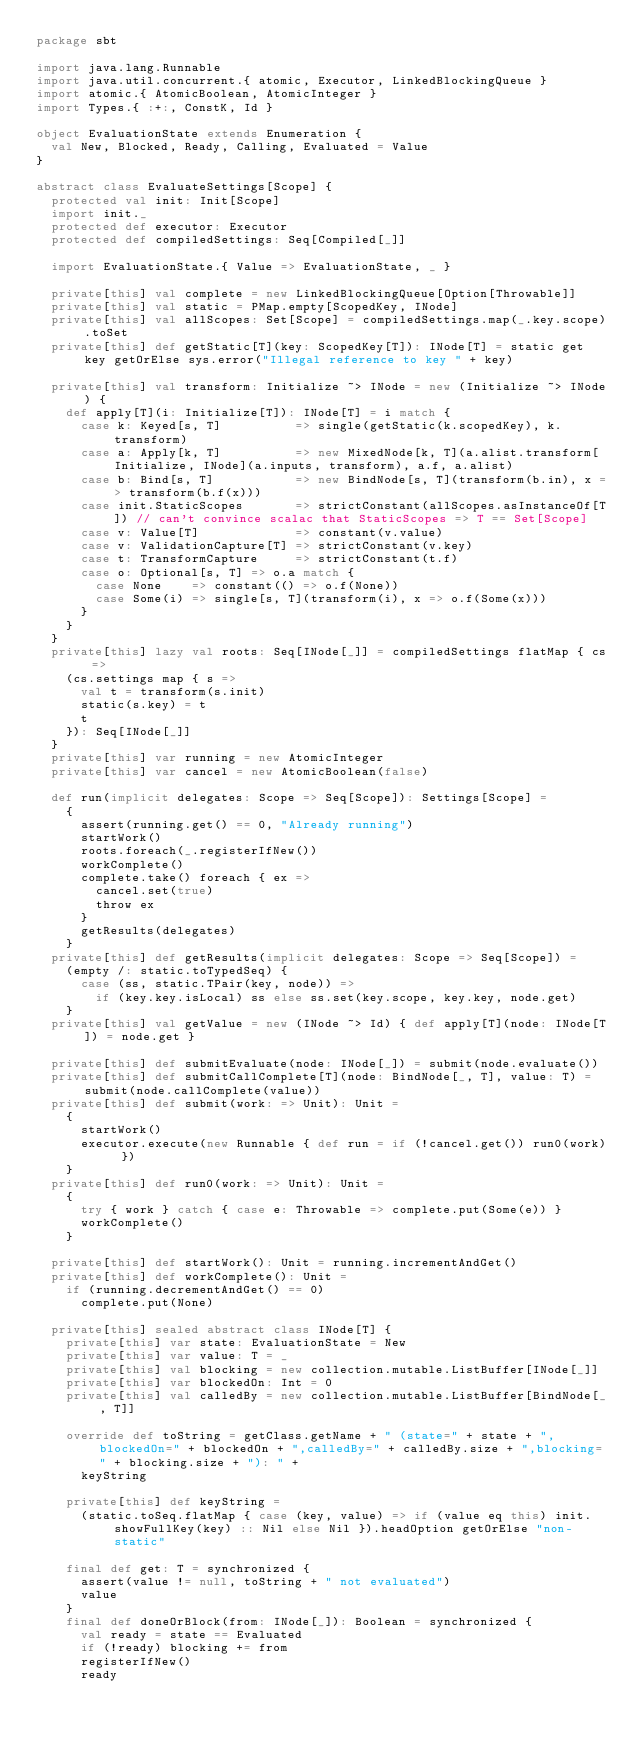<code> <loc_0><loc_0><loc_500><loc_500><_Scala_>package sbt

import java.lang.Runnable
import java.util.concurrent.{ atomic, Executor, LinkedBlockingQueue }
import atomic.{ AtomicBoolean, AtomicInteger }
import Types.{ :+:, ConstK, Id }

object EvaluationState extends Enumeration {
  val New, Blocked, Ready, Calling, Evaluated = Value
}

abstract class EvaluateSettings[Scope] {
  protected val init: Init[Scope]
  import init._
  protected def executor: Executor
  protected def compiledSettings: Seq[Compiled[_]]

  import EvaluationState.{ Value => EvaluationState, _ }

  private[this] val complete = new LinkedBlockingQueue[Option[Throwable]]
  private[this] val static = PMap.empty[ScopedKey, INode]
  private[this] val allScopes: Set[Scope] = compiledSettings.map(_.key.scope).toSet
  private[this] def getStatic[T](key: ScopedKey[T]): INode[T] = static get key getOrElse sys.error("Illegal reference to key " + key)

  private[this] val transform: Initialize ~> INode = new (Initialize ~> INode) {
    def apply[T](i: Initialize[T]): INode[T] = i match {
      case k: Keyed[s, T]          => single(getStatic(k.scopedKey), k.transform)
      case a: Apply[k, T]          => new MixedNode[k, T](a.alist.transform[Initialize, INode](a.inputs, transform), a.f, a.alist)
      case b: Bind[s, T]           => new BindNode[s, T](transform(b.in), x => transform(b.f(x)))
      case init.StaticScopes       => strictConstant(allScopes.asInstanceOf[T]) // can't convince scalac that StaticScopes => T == Set[Scope]
      case v: Value[T]             => constant(v.value)
      case v: ValidationCapture[T] => strictConstant(v.key)
      case t: TransformCapture     => strictConstant(t.f)
      case o: Optional[s, T] => o.a match {
        case None    => constant(() => o.f(None))
        case Some(i) => single[s, T](transform(i), x => o.f(Some(x)))
      }
    }
  }
  private[this] lazy val roots: Seq[INode[_]] = compiledSettings flatMap { cs =>
    (cs.settings map { s =>
      val t = transform(s.init)
      static(s.key) = t
      t
    }): Seq[INode[_]]
  }
  private[this] var running = new AtomicInteger
  private[this] var cancel = new AtomicBoolean(false)

  def run(implicit delegates: Scope => Seq[Scope]): Settings[Scope] =
    {
      assert(running.get() == 0, "Already running")
      startWork()
      roots.foreach(_.registerIfNew())
      workComplete()
      complete.take() foreach { ex =>
        cancel.set(true)
        throw ex
      }
      getResults(delegates)
    }
  private[this] def getResults(implicit delegates: Scope => Seq[Scope]) =
    (empty /: static.toTypedSeq) {
      case (ss, static.TPair(key, node)) =>
        if (key.key.isLocal) ss else ss.set(key.scope, key.key, node.get)
    }
  private[this] val getValue = new (INode ~> Id) { def apply[T](node: INode[T]) = node.get }

  private[this] def submitEvaluate(node: INode[_]) = submit(node.evaluate())
  private[this] def submitCallComplete[T](node: BindNode[_, T], value: T) = submit(node.callComplete(value))
  private[this] def submit(work: => Unit): Unit =
    {
      startWork()
      executor.execute(new Runnable { def run = if (!cancel.get()) run0(work) })
    }
  private[this] def run0(work: => Unit): Unit =
    {
      try { work } catch { case e: Throwable => complete.put(Some(e)) }
      workComplete()
    }

  private[this] def startWork(): Unit = running.incrementAndGet()
  private[this] def workComplete(): Unit =
    if (running.decrementAndGet() == 0)
      complete.put(None)

  private[this] sealed abstract class INode[T] {
    private[this] var state: EvaluationState = New
    private[this] var value: T = _
    private[this] val blocking = new collection.mutable.ListBuffer[INode[_]]
    private[this] var blockedOn: Int = 0
    private[this] val calledBy = new collection.mutable.ListBuffer[BindNode[_, T]]

    override def toString = getClass.getName + " (state=" + state + ",blockedOn=" + blockedOn + ",calledBy=" + calledBy.size + ",blocking=" + blocking.size + "): " +
      keyString

    private[this] def keyString =
      (static.toSeq.flatMap { case (key, value) => if (value eq this) init.showFullKey(key) :: Nil else Nil }).headOption getOrElse "non-static"

    final def get: T = synchronized {
      assert(value != null, toString + " not evaluated")
      value
    }
    final def doneOrBlock(from: INode[_]): Boolean = synchronized {
      val ready = state == Evaluated
      if (!ready) blocking += from
      registerIfNew()
      ready</code> 